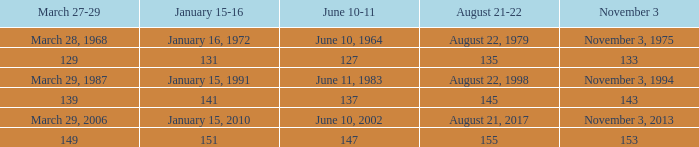What is shown for november 3 when june 10-11 is june 10, 1964? November 3, 1975. 